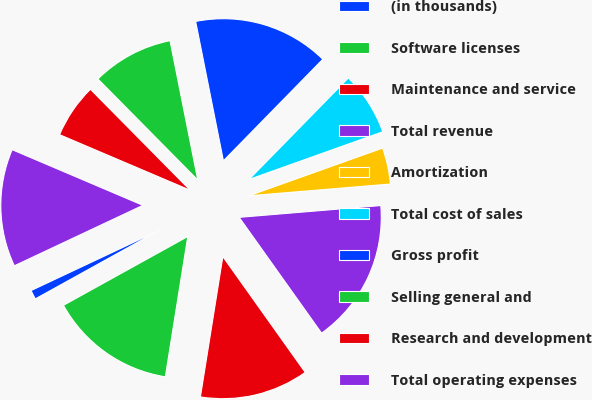<chart> <loc_0><loc_0><loc_500><loc_500><pie_chart><fcel>(in thousands)<fcel>Software licenses<fcel>Maintenance and service<fcel>Total revenue<fcel>Amortization<fcel>Total cost of sales<fcel>Gross profit<fcel>Selling general and<fcel>Research and development<fcel>Total operating expenses<nl><fcel>1.05%<fcel>14.43%<fcel>12.37%<fcel>16.48%<fcel>4.13%<fcel>7.22%<fcel>15.46%<fcel>9.28%<fcel>6.19%<fcel>13.4%<nl></chart> 